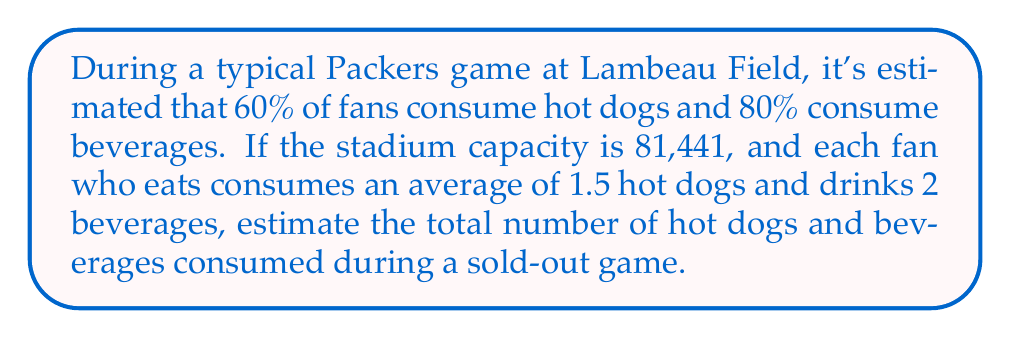Can you answer this question? Let's break this down step-by-step:

1. Calculate the number of fans consuming hot dogs:
   $$ 81,441 \times 0.60 = 48,864.6 \approx 48,865 \text{ fans} $$

2. Calculate the number of hot dogs consumed:
   $$ 48,865 \times 1.5 = 73,297.5 \approx 73,298 \text{ hot dogs} $$

3. Calculate the number of fans consuming beverages:
   $$ 81,441 \times 0.80 = 65,152.8 \approx 65,153 \text{ fans} $$

4. Calculate the number of beverages consumed:
   $$ 65,153 \times 2 = 130,306 \text{ beverages} $$

5. Sum up the total number of hot dogs and beverages:
   $$ 73,298 + 130,306 = 203,604 $$

Therefore, the estimated total number of hot dogs and beverages consumed during a typical sold-out game at Lambeau Field is 203,604.
Answer: 203,604 